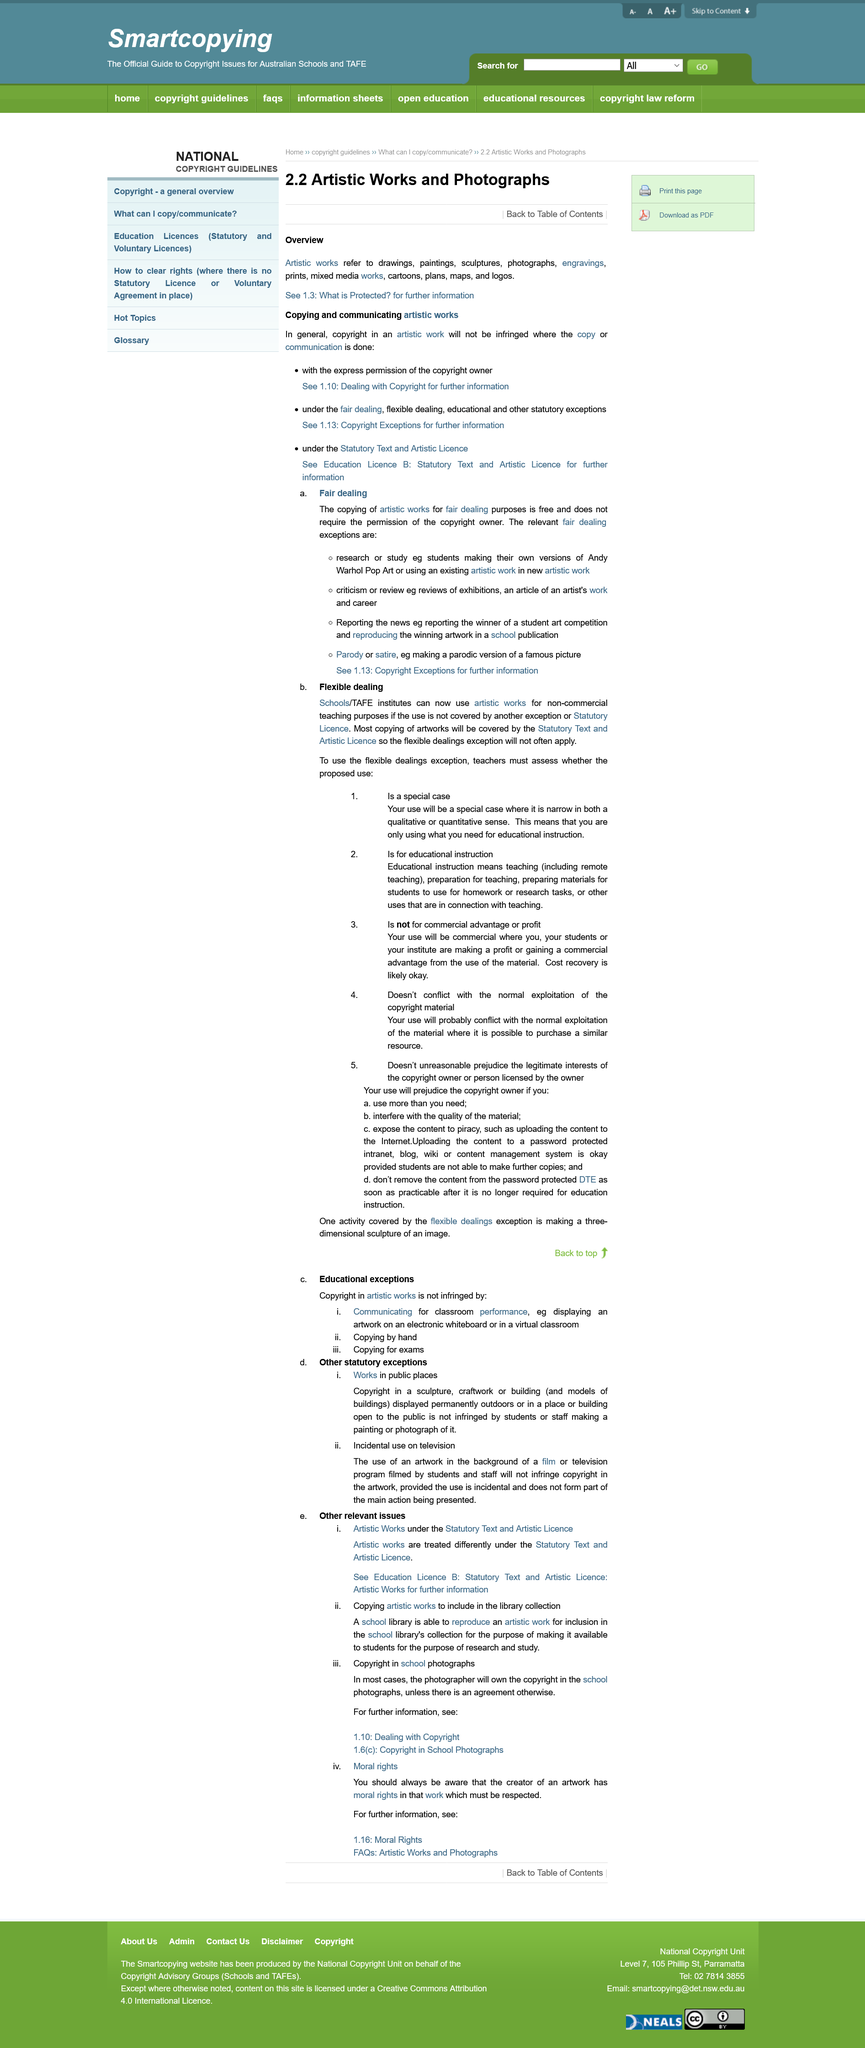Indicate a few pertinent items in this graphic. Under the Copyright Act, a special case allows for the use of a copyrighted work for educational instruction only under the flexible dealing exemption. Copyright is not infringed by students or staff making a painting or photograph of a work in a public place. Flexible dealing in schools will be assessed by teachers, The term "artistic works" refers to drawings, paintings, sculptures, photographs, engravings, prints, mixed media works, cartoons, plans, maps, and logos. Works in public spaces are defined as sculptures, craftworks, or buildings displayed permanently outdoors or in a place or building open to the public. 